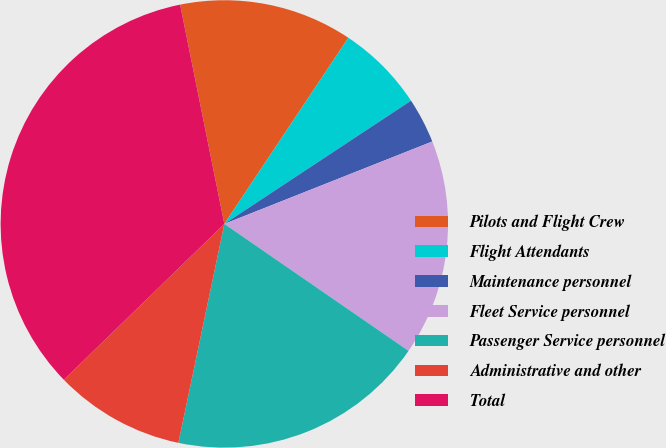<chart> <loc_0><loc_0><loc_500><loc_500><pie_chart><fcel>Pilots and Flight Crew<fcel>Flight Attendants<fcel>Maintenance personnel<fcel>Fleet Service personnel<fcel>Passenger Service personnel<fcel>Administrative and other<fcel>Total<nl><fcel>12.52%<fcel>6.36%<fcel>3.28%<fcel>15.61%<fcel>18.69%<fcel>9.44%<fcel>34.1%<nl></chart> 